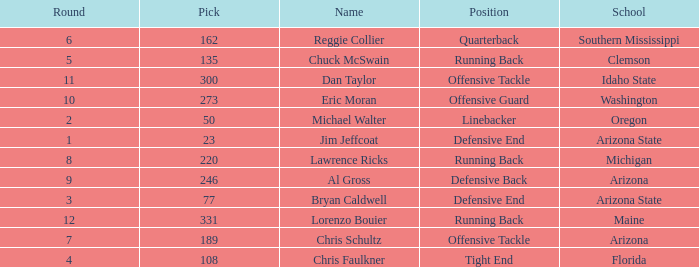What is the number of the pick for round 11? 300.0. 